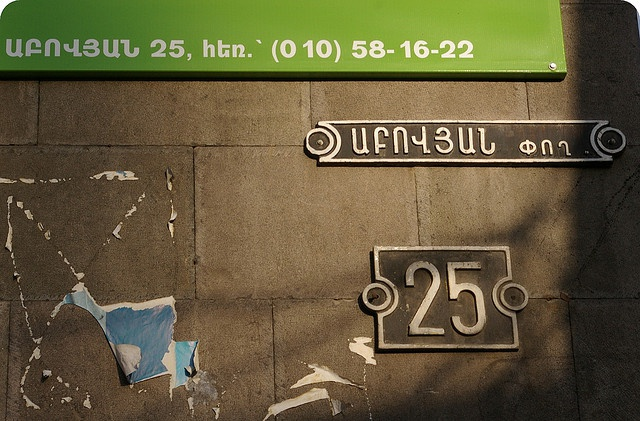Describe the objects in this image and their specific colors. I can see various objects in this image with different colors. 